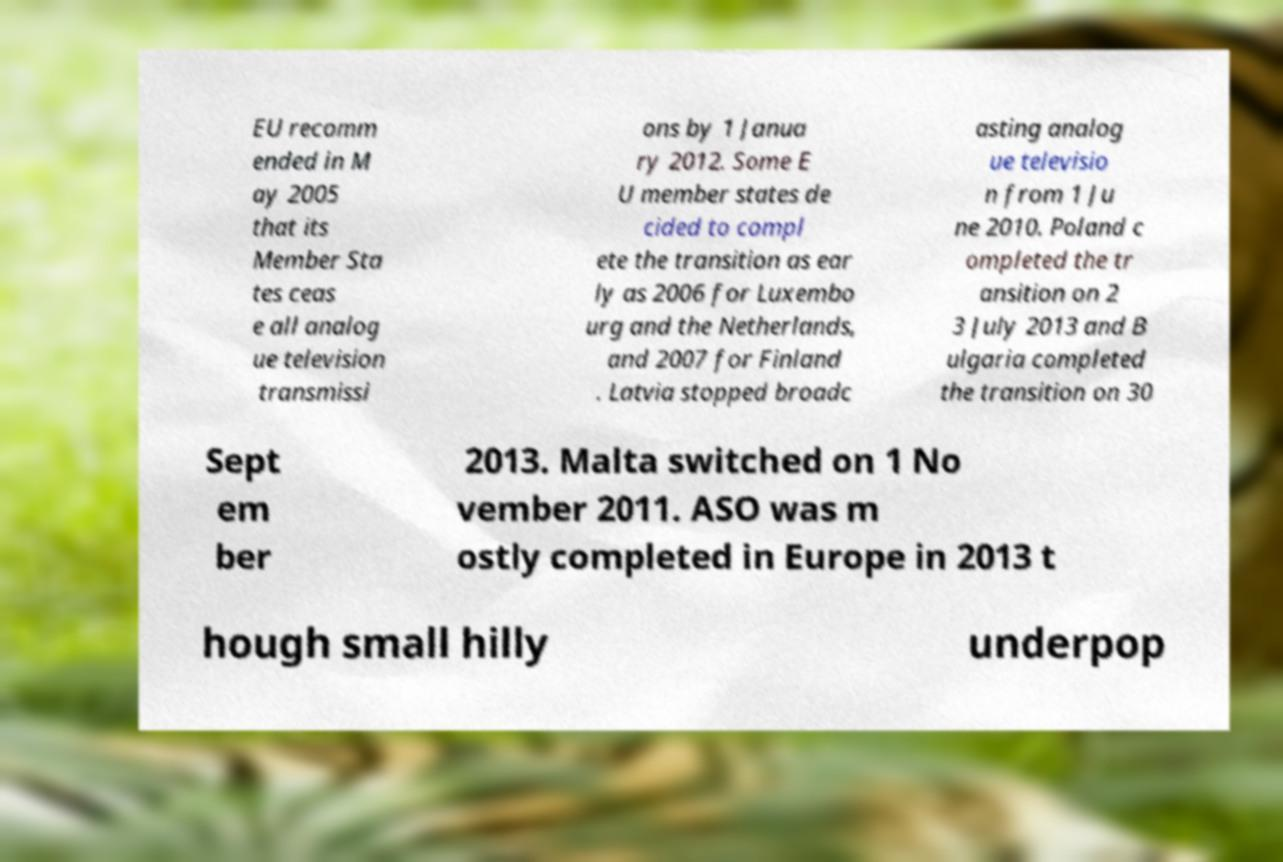Could you assist in decoding the text presented in this image and type it out clearly? EU recomm ended in M ay 2005 that its Member Sta tes ceas e all analog ue television transmissi ons by 1 Janua ry 2012. Some E U member states de cided to compl ete the transition as ear ly as 2006 for Luxembo urg and the Netherlands, and 2007 for Finland . Latvia stopped broadc asting analog ue televisio n from 1 Ju ne 2010. Poland c ompleted the tr ansition on 2 3 July 2013 and B ulgaria completed the transition on 30 Sept em ber 2013. Malta switched on 1 No vember 2011. ASO was m ostly completed in Europe in 2013 t hough small hilly underpop 